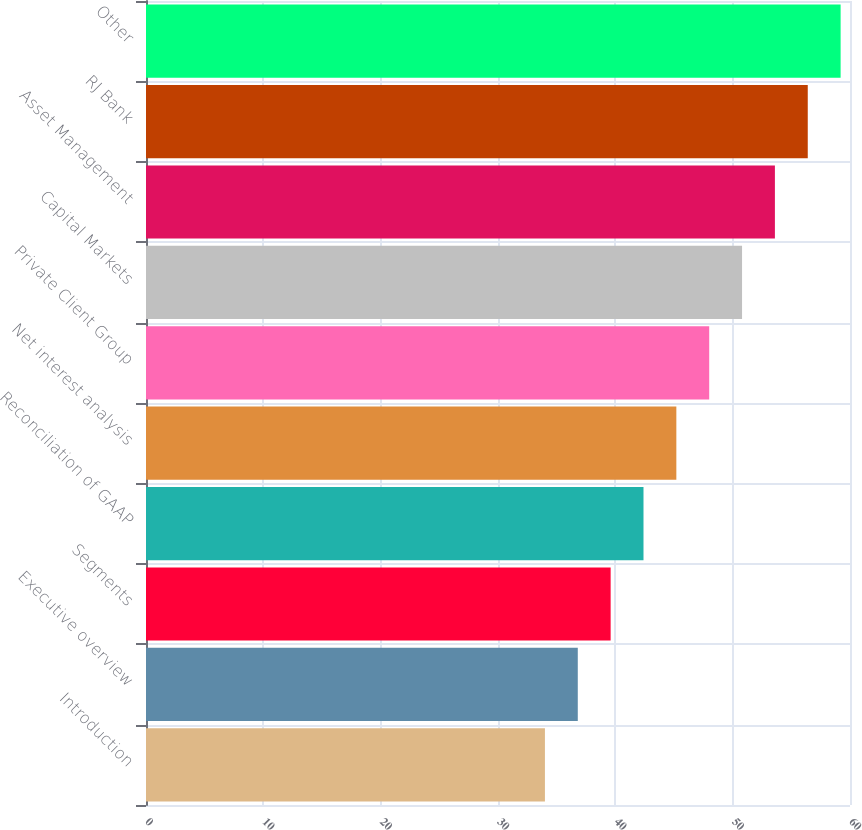<chart> <loc_0><loc_0><loc_500><loc_500><bar_chart><fcel>Introduction<fcel>Executive overview<fcel>Segments<fcel>Reconciliation of GAAP<fcel>Net interest analysis<fcel>Private Client Group<fcel>Capital Markets<fcel>Asset Management<fcel>RJ Bank<fcel>Other<nl><fcel>34<fcel>36.8<fcel>39.6<fcel>42.4<fcel>45.2<fcel>48<fcel>50.8<fcel>53.6<fcel>56.4<fcel>59.2<nl></chart> 